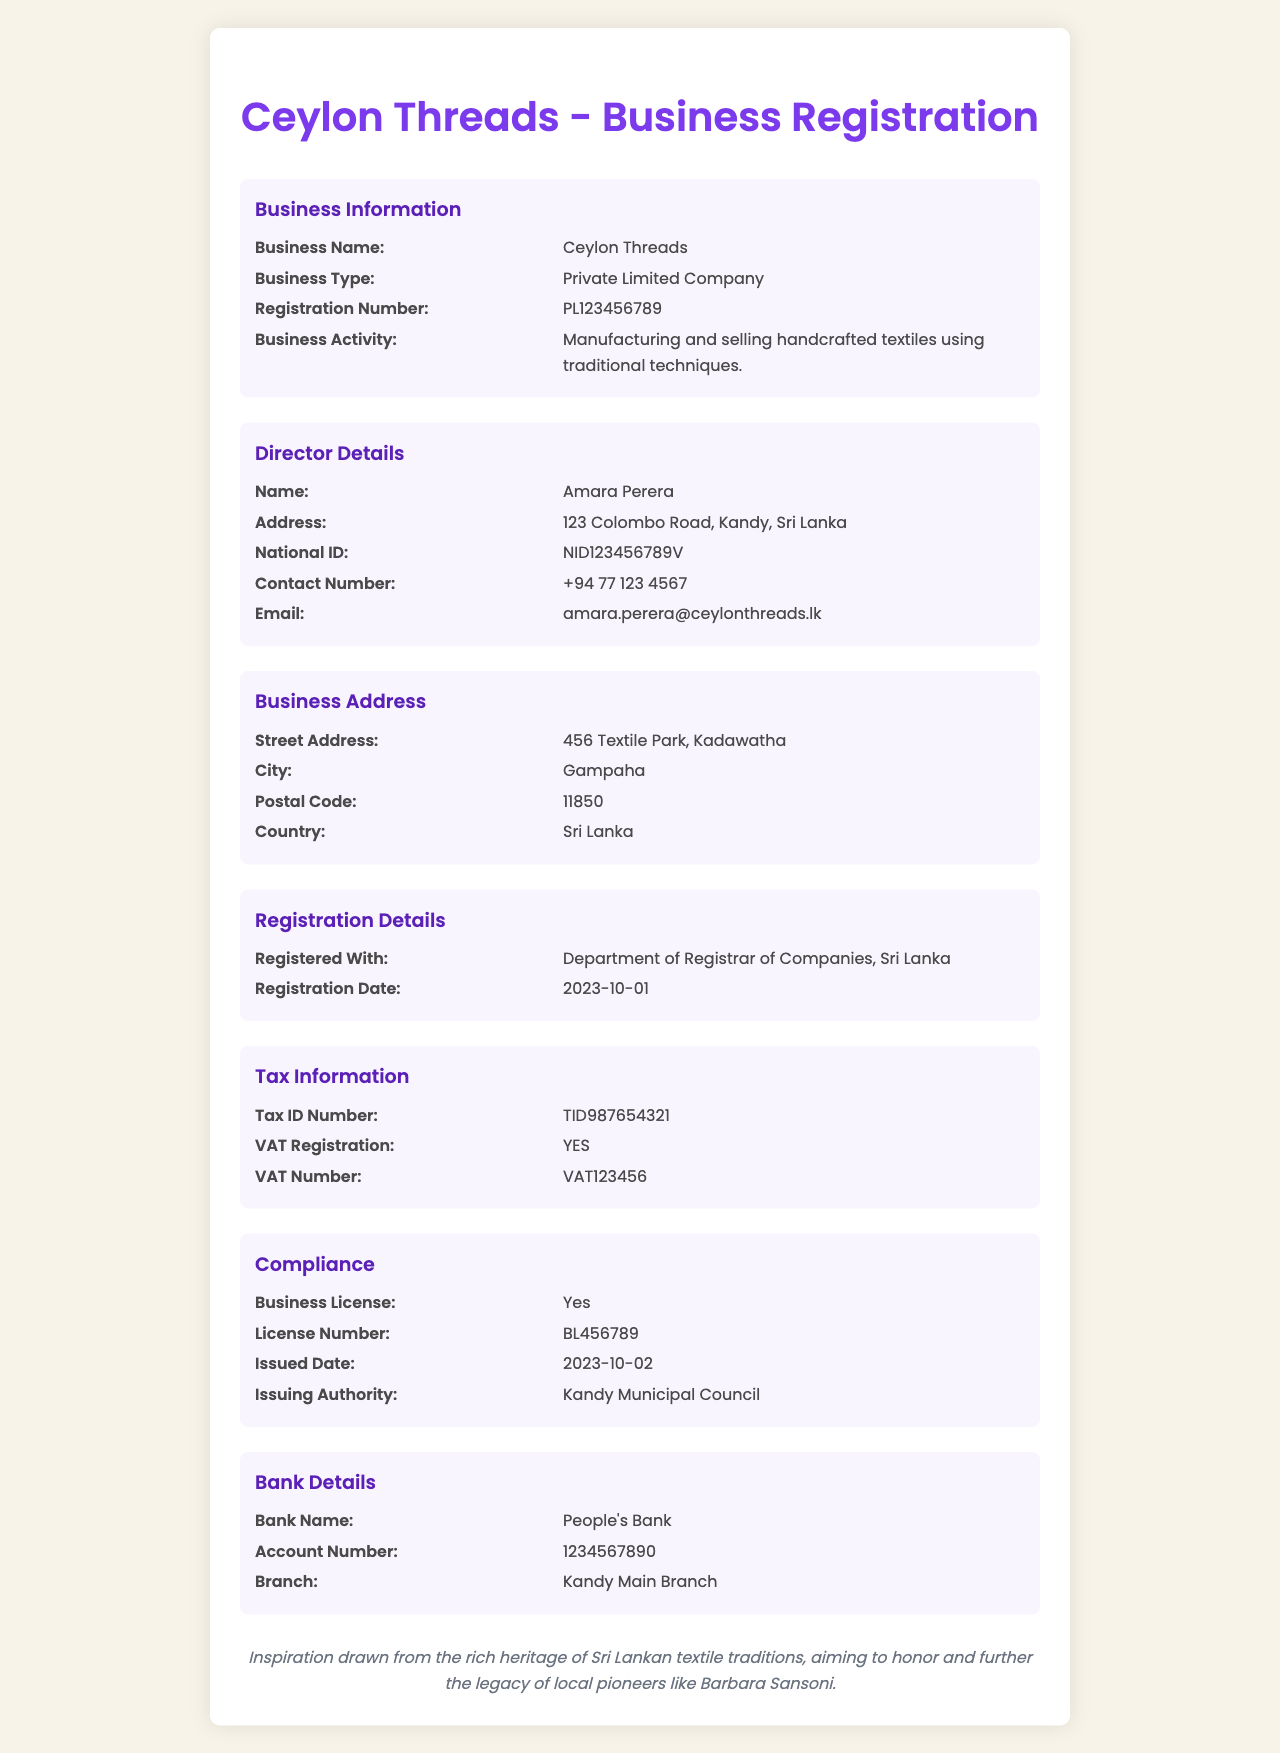What is the business name? The business name is stated in the document under Business Information.
Answer: Ceylon Threads What is the registration number? The registration number can be found in the Business Information section.
Answer: PL123456789 Who is the director of the company? The name of the director is listed in the Director Details section.
Answer: Amara Perera What is the business activity? The business activity describes what the company does, found in the Business Information section.
Answer: Manufacturing and selling handcrafted textiles using traditional techniques When was the business registered? The registration date is mentioned in the Registration Details section.
Answer: 2023-10-01 Where is the business address? The business address is detailed in the Business Address section, including street and city.
Answer: 456 Textile Park, Kadawatha Is the business VAT registered? The VAT registration status is provided in the Tax Information section.
Answer: YES What is the license number? The license number is specified under the Compliance section.
Answer: BL456789 Which bank is associated with the company? The bank name is stated in the Bank Details section.
Answer: People's Bank 